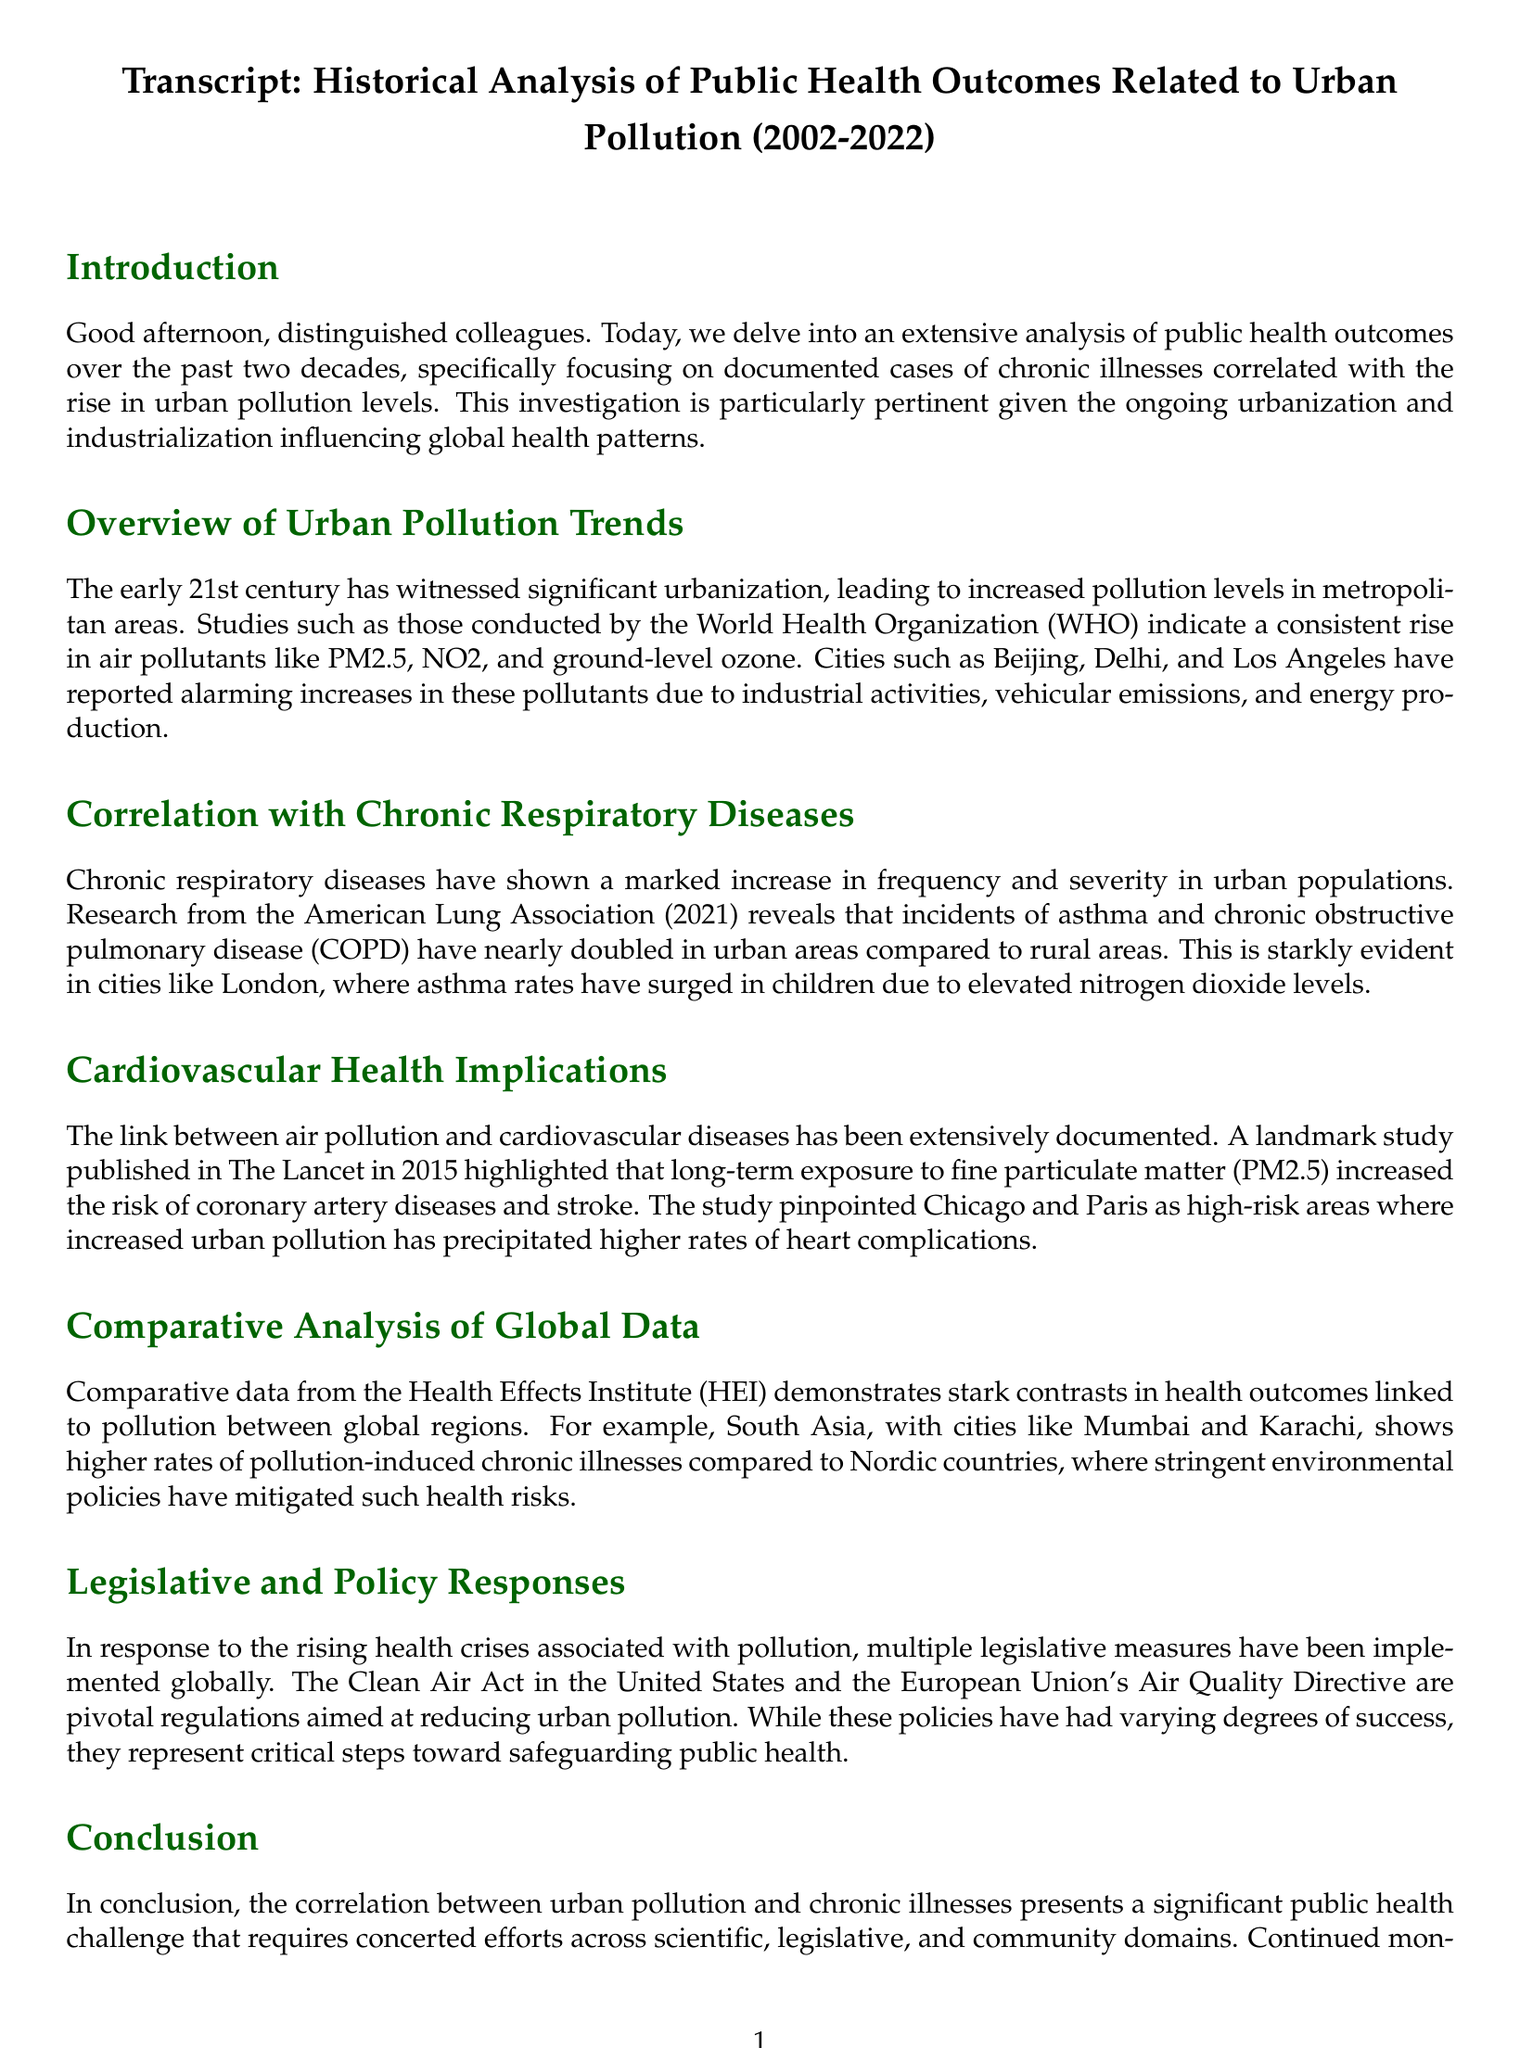What is the time frame of the analysis? The document discusses public health outcomes related to urban pollution within the period from 2002 to 2022.
Answer: 2002 to 2022 Which pollutants are mentioned as rising in urban areas? The document lists PM2.5, NO2, and ground-level ozone as the air pollutants that have significantly increased.
Answer: PM2.5, NO2, ground-level ozone Which organization conducted research revealing increased respiratory diseases? The American Lung Association is identified as the organization that reported increased incidents of respiratory diseases.
Answer: American Lung Association What chronic illness has nearly doubled in urban areas? The document indicates that asthma incidents have nearly doubled in urban populations compared to rural areas.
Answer: Asthma Which cities are noted for high rates of cardiovascular diseases? Chicago and Paris are specified as high-risk areas for increased cardiovascular diseases linked to pollution.
Answer: Chicago, Paris What legislative measures have been implemented in response to pollution? The Clean Air Act in the United States is cited as one of the critical legislative measures to reduce urban pollution.
Answer: Clean Air Act Which region shows higher rates of pollution-induced chronic illnesses? South Asia is highlighted as a region with higher rates of pollution-induced chronic illnesses compared to other regions.
Answer: South Asia What is the purpose of the European Union's Air Quality Directive? The directive is aimed at reducing urban pollution and safeguarding public health as indicated in the document.
Answer: Reducing urban pollution What is the key takeaway from the conclusion? The conclusion emphasizes the need for concerted efforts to combat health challenges resulting from urban pollution.
Answer: Concerted efforts needed 